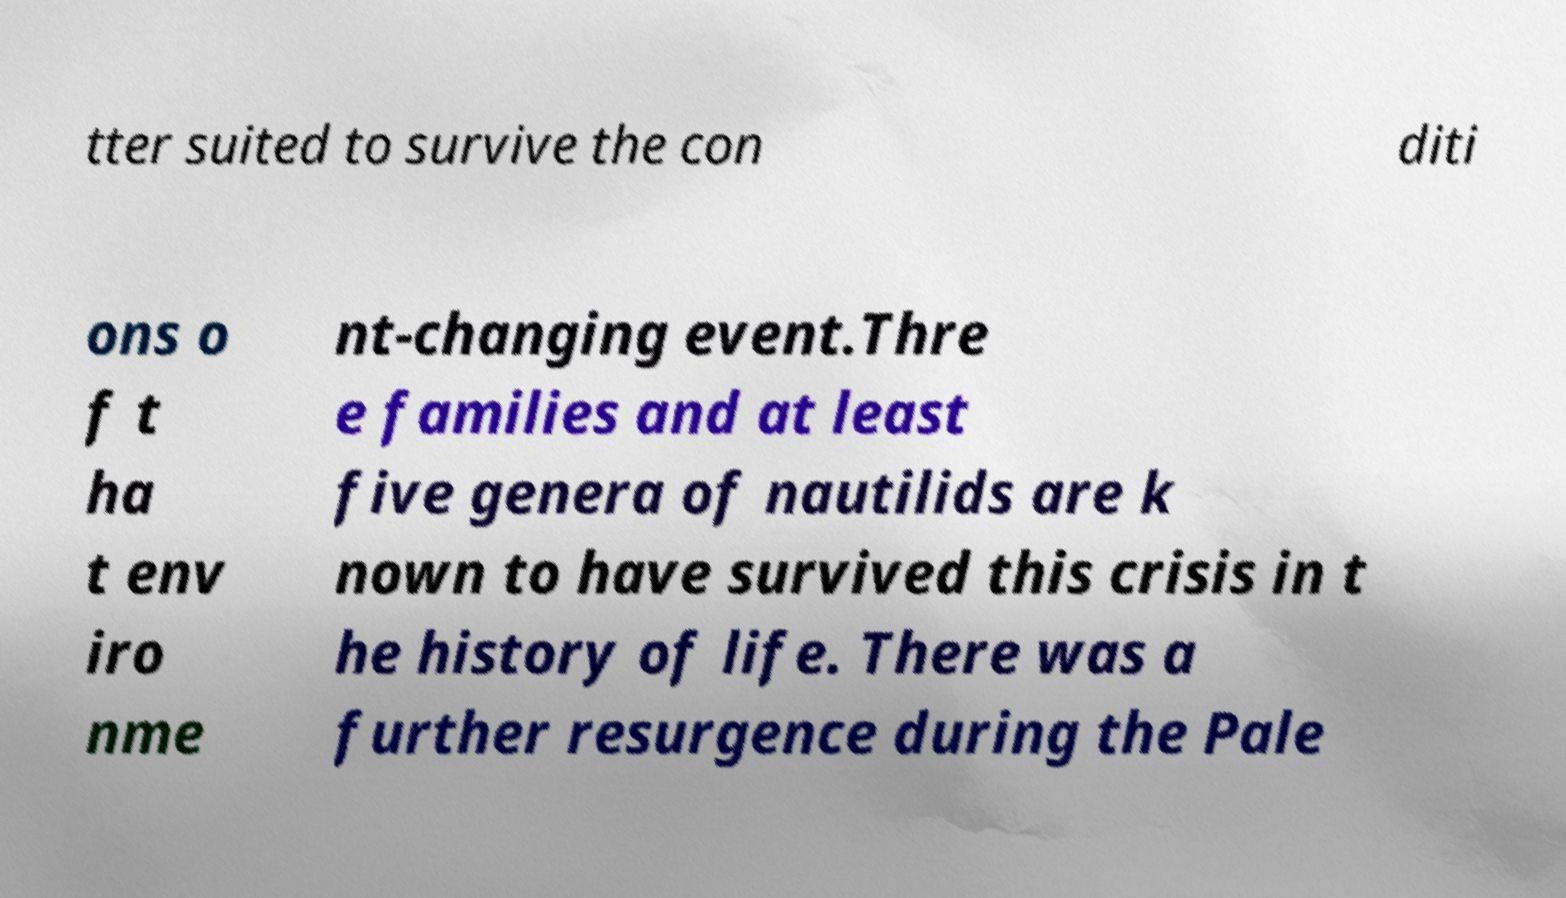Could you assist in decoding the text presented in this image and type it out clearly? tter suited to survive the con diti ons o f t ha t env iro nme nt-changing event.Thre e families and at least five genera of nautilids are k nown to have survived this crisis in t he history of life. There was a further resurgence during the Pale 